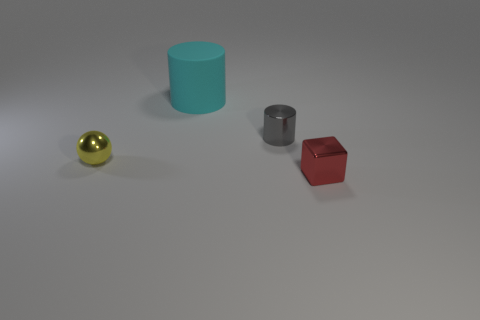Could you infer anything about the setting or purpose of these objects from their arrangement? The objects are arranged with space between them on a neutral background, suggesting a setting for display or examination. The layout might be used for a demonstration of shapes, colors, or materials, perhaps in an educational context. 